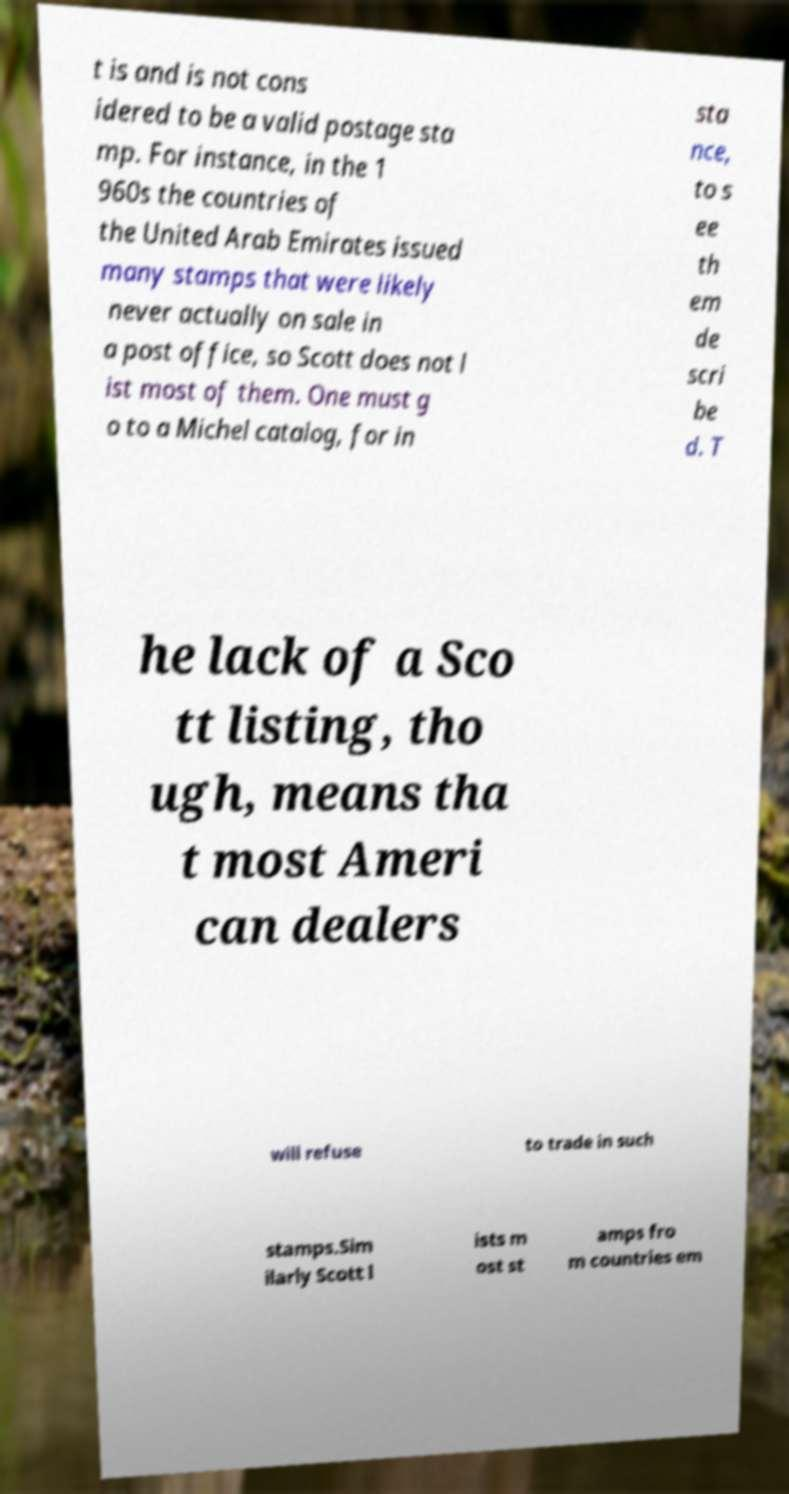Can you accurately transcribe the text from the provided image for me? t is and is not cons idered to be a valid postage sta mp. For instance, in the 1 960s the countries of the United Arab Emirates issued many stamps that were likely never actually on sale in a post office, so Scott does not l ist most of them. One must g o to a Michel catalog, for in sta nce, to s ee th em de scri be d. T he lack of a Sco tt listing, tho ugh, means tha t most Ameri can dealers will refuse to trade in such stamps.Sim ilarly Scott l ists m ost st amps fro m countries em 